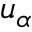Convert formula to latex. <formula><loc_0><loc_0><loc_500><loc_500>u _ { \alpha }</formula> 